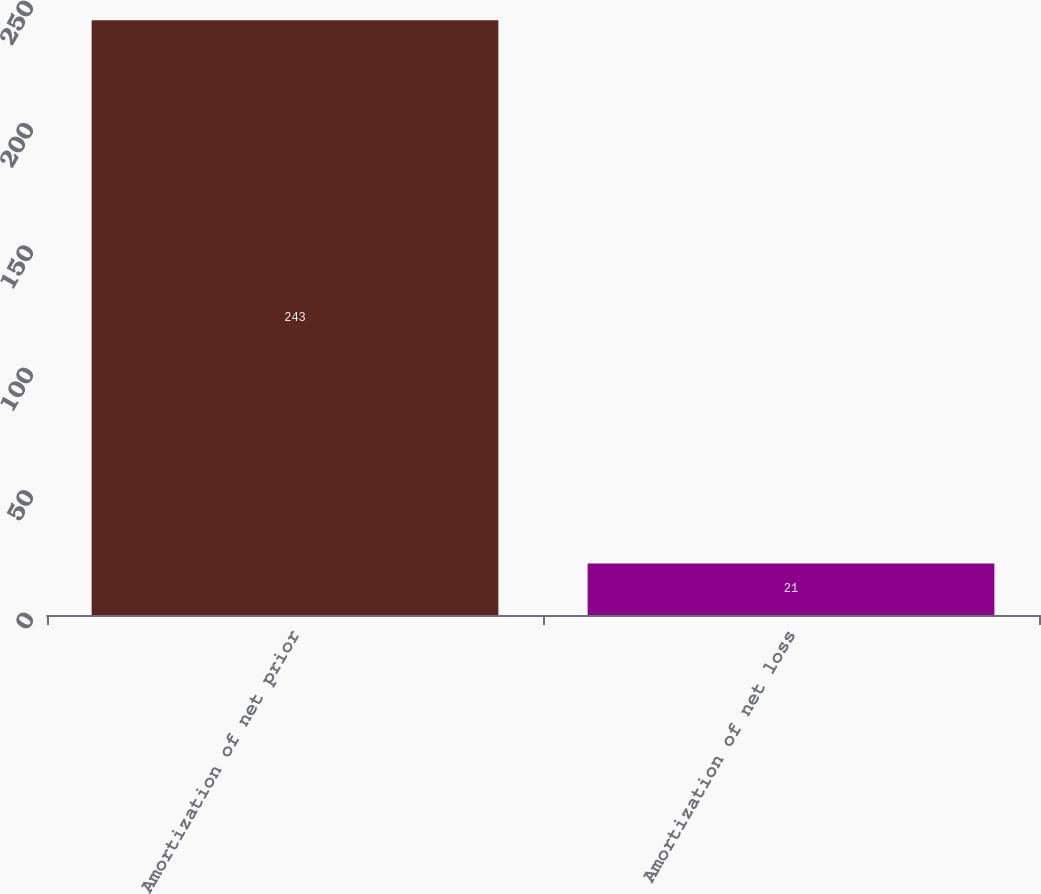Convert chart. <chart><loc_0><loc_0><loc_500><loc_500><bar_chart><fcel>Amortization of net prior<fcel>Amortization of net loss<nl><fcel>243<fcel>21<nl></chart> 